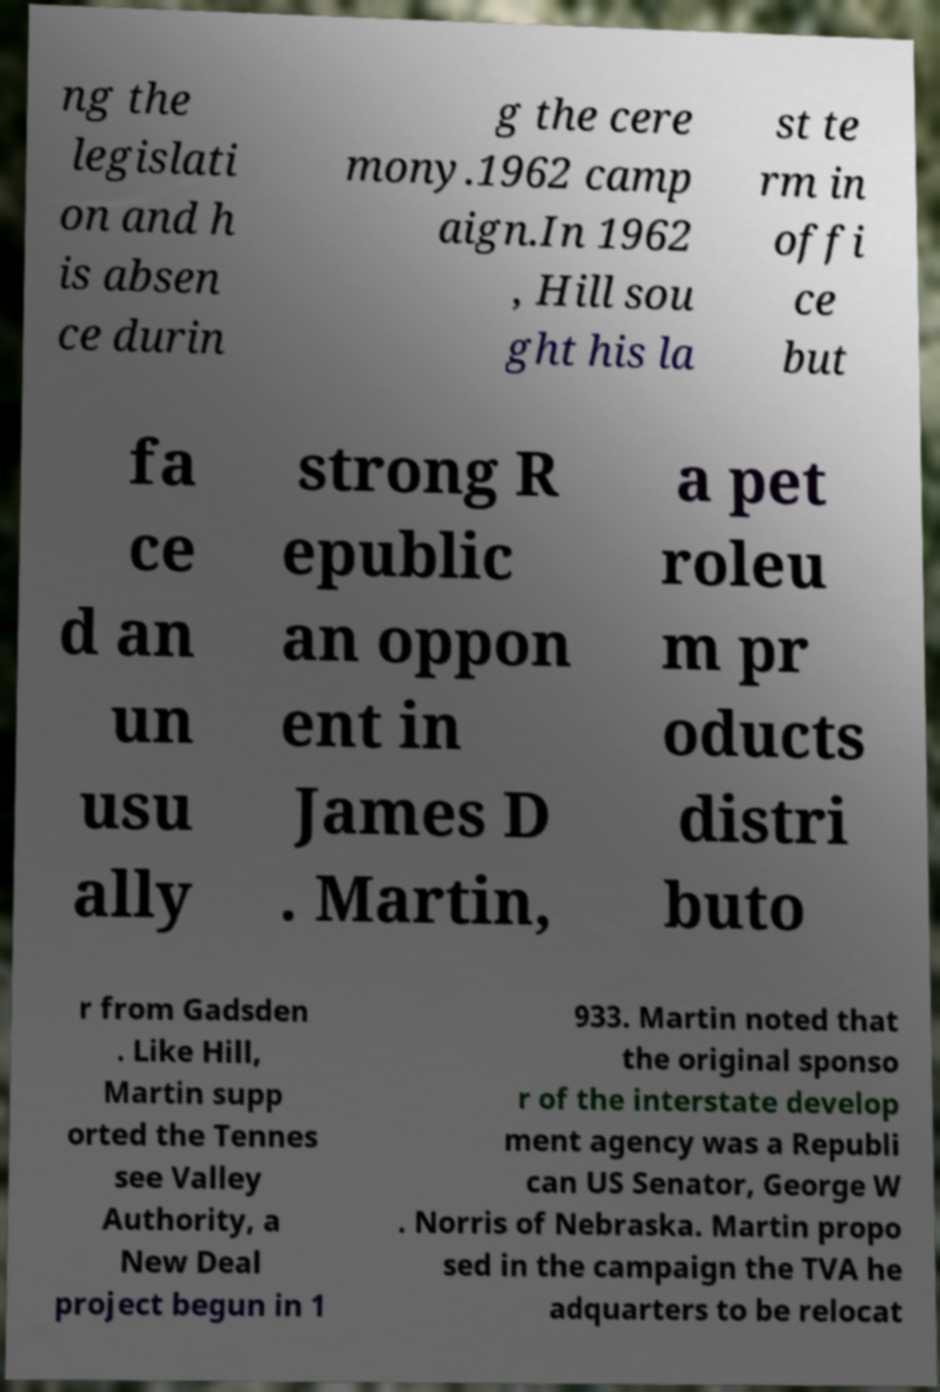Can you read and provide the text displayed in the image?This photo seems to have some interesting text. Can you extract and type it out for me? ng the legislati on and h is absen ce durin g the cere mony.1962 camp aign.In 1962 , Hill sou ght his la st te rm in offi ce but fa ce d an un usu ally strong R epublic an oppon ent in James D . Martin, a pet roleu m pr oducts distri buto r from Gadsden . Like Hill, Martin supp orted the Tennes see Valley Authority, a New Deal project begun in 1 933. Martin noted that the original sponso r of the interstate develop ment agency was a Republi can US Senator, George W . Norris of Nebraska. Martin propo sed in the campaign the TVA he adquarters to be relocat 